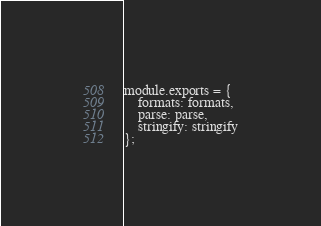Convert code to text. <code><loc_0><loc_0><loc_500><loc_500><_JavaScript_>
module.exports = {
    formats: formats,
    parse: parse,
    stringify: stringify
};
</code> 